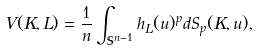<formula> <loc_0><loc_0><loc_500><loc_500>\ V ( K , L ) = \frac { 1 } { n } \int _ { \mathbb { S } ^ { n - 1 } } h _ { L } ( u ) ^ { p } d S _ { p } ( K , u ) ,</formula> 